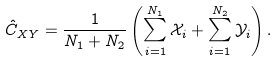Convert formula to latex. <formula><loc_0><loc_0><loc_500><loc_500>\hat { C } _ { X Y } = \frac { 1 } { N _ { 1 } + N _ { 2 } } \left ( \sum ^ { N _ { 1 } } _ { i = 1 } \mathcal { X } _ { i } + \sum ^ { N _ { 2 } } _ { i = 1 } \mathcal { Y } _ { i } \right ) .</formula> 